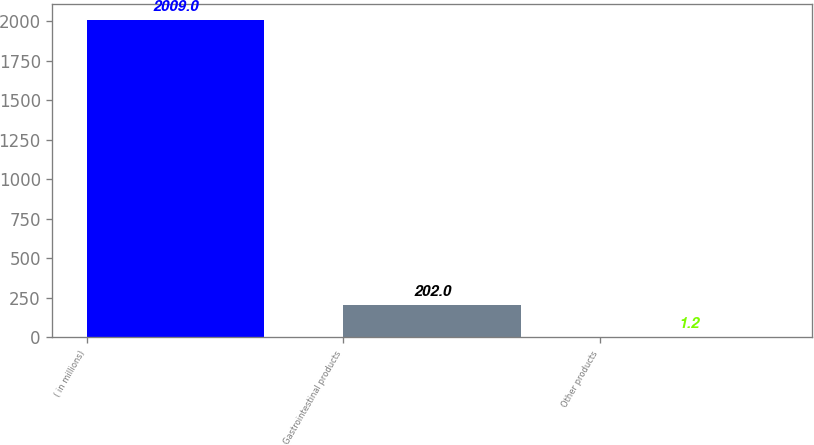<chart> <loc_0><loc_0><loc_500><loc_500><bar_chart><fcel>( in millions)<fcel>Gastrointestinal products<fcel>Other products<nl><fcel>2009<fcel>202<fcel>1.2<nl></chart> 